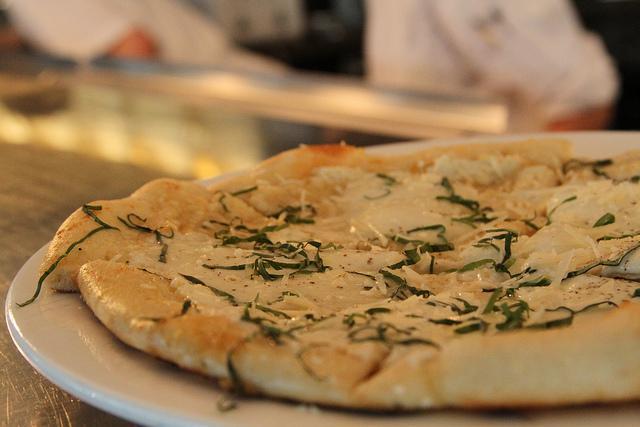How many people can you see?
Give a very brief answer. 2. 